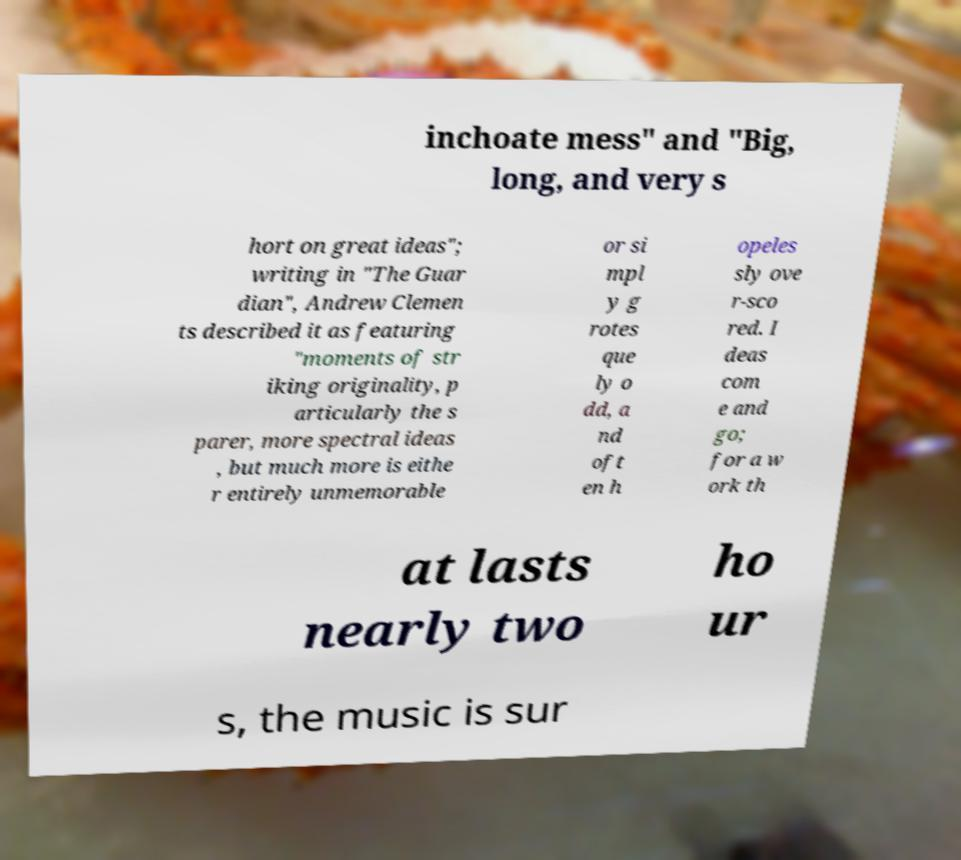Could you assist in decoding the text presented in this image and type it out clearly? inchoate mess" and "Big, long, and very s hort on great ideas"; writing in "The Guar dian", Andrew Clemen ts described it as featuring "moments of str iking originality, p articularly the s parer, more spectral ideas , but much more is eithe r entirely unmemorable or si mpl y g rotes que ly o dd, a nd oft en h opeles sly ove r-sco red. I deas com e and go; for a w ork th at lasts nearly two ho ur s, the music is sur 